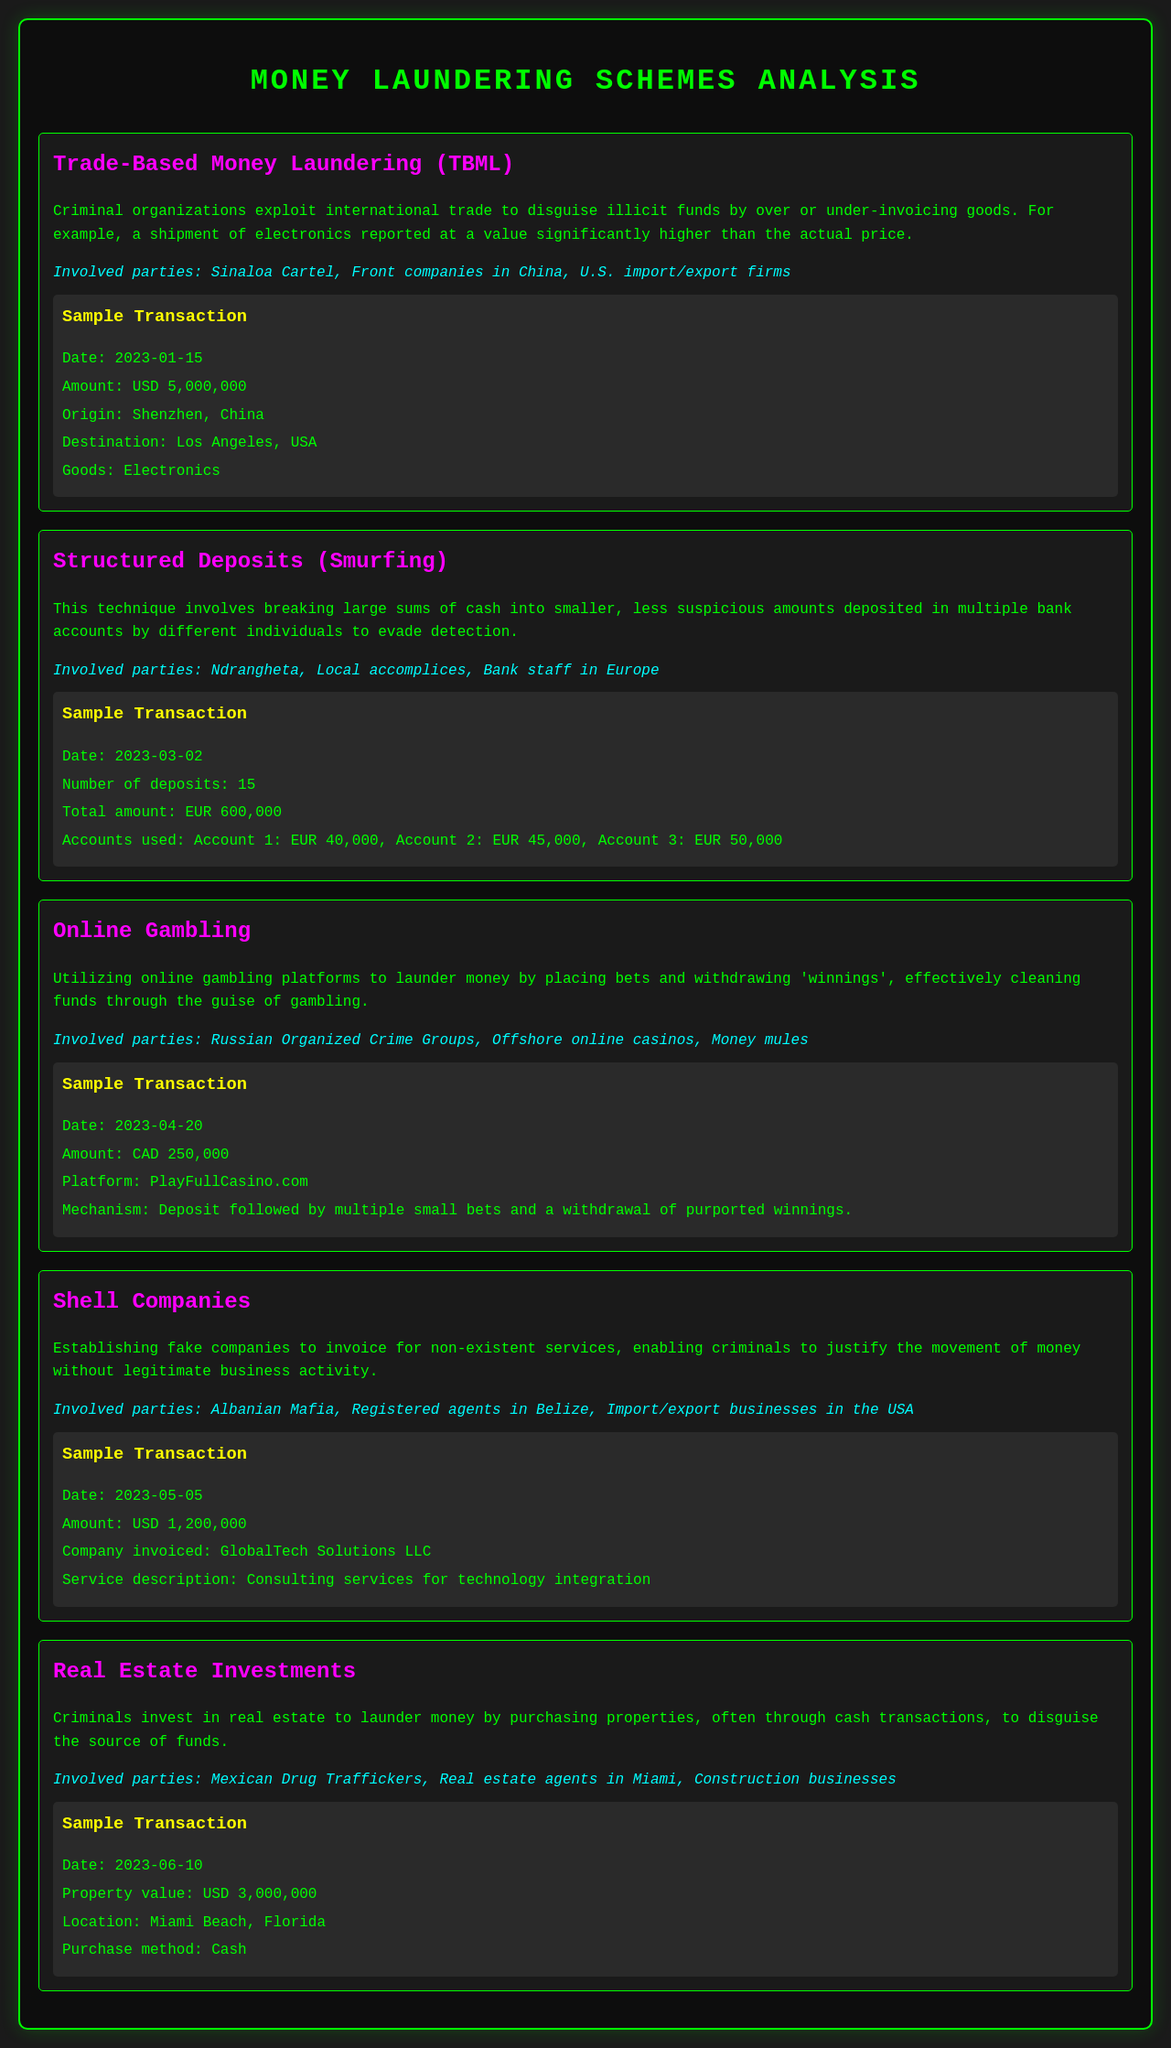What is the method used by the Sinaloa Cartel? The Sinaloa Cartel uses Trade-Based Money Laundering (TBML) to disguise illicit funds through over or under-invoicing goods.
Answer: Trade-Based Money Laundering (TBML) What is the sample transaction amount for Structured Deposits? The document specifies a total amount of 600,000 Euros for the sample transaction related to Structured Deposits.
Answer: EUR 600,000 Which party is involved in the Online Gambling scheme? Russian Organized Crime Groups are listed as one of the involved parties in the Online Gambling scheme.
Answer: Russian Organized Crime Groups What type of companies do the Albanian Mafia establish? The Albanian Mafia establishes fake companies to facilitate their money laundering activities.
Answer: Fake companies What was the property value for the Real Estate Investment transaction? The document states the property value for the Real Estate Investment transaction was 3,000,000 dollars.
Answer: USD 3,000,000 How many deposits were made in the Structured Deposits example? The number of deposits made in the Structured Deposits example is 15.
Answer: 15 What is the purpose of Shell Companies as mentioned in the document? Shell Companies are used to invoice for non-existent services, allowing criminals to justify the movement of money.
Answer: Invoice for non-existent services On what date was the third sample transaction conducted? The date of the third sample transaction related to Online Gambling was April 20, 2023.
Answer: 2023-04-20 Where is the origin of the goods in the TBML example? The origin of the goods in the Trade-Based Money Laundering example is Shenzhen, China.
Answer: Shenzhen, China 